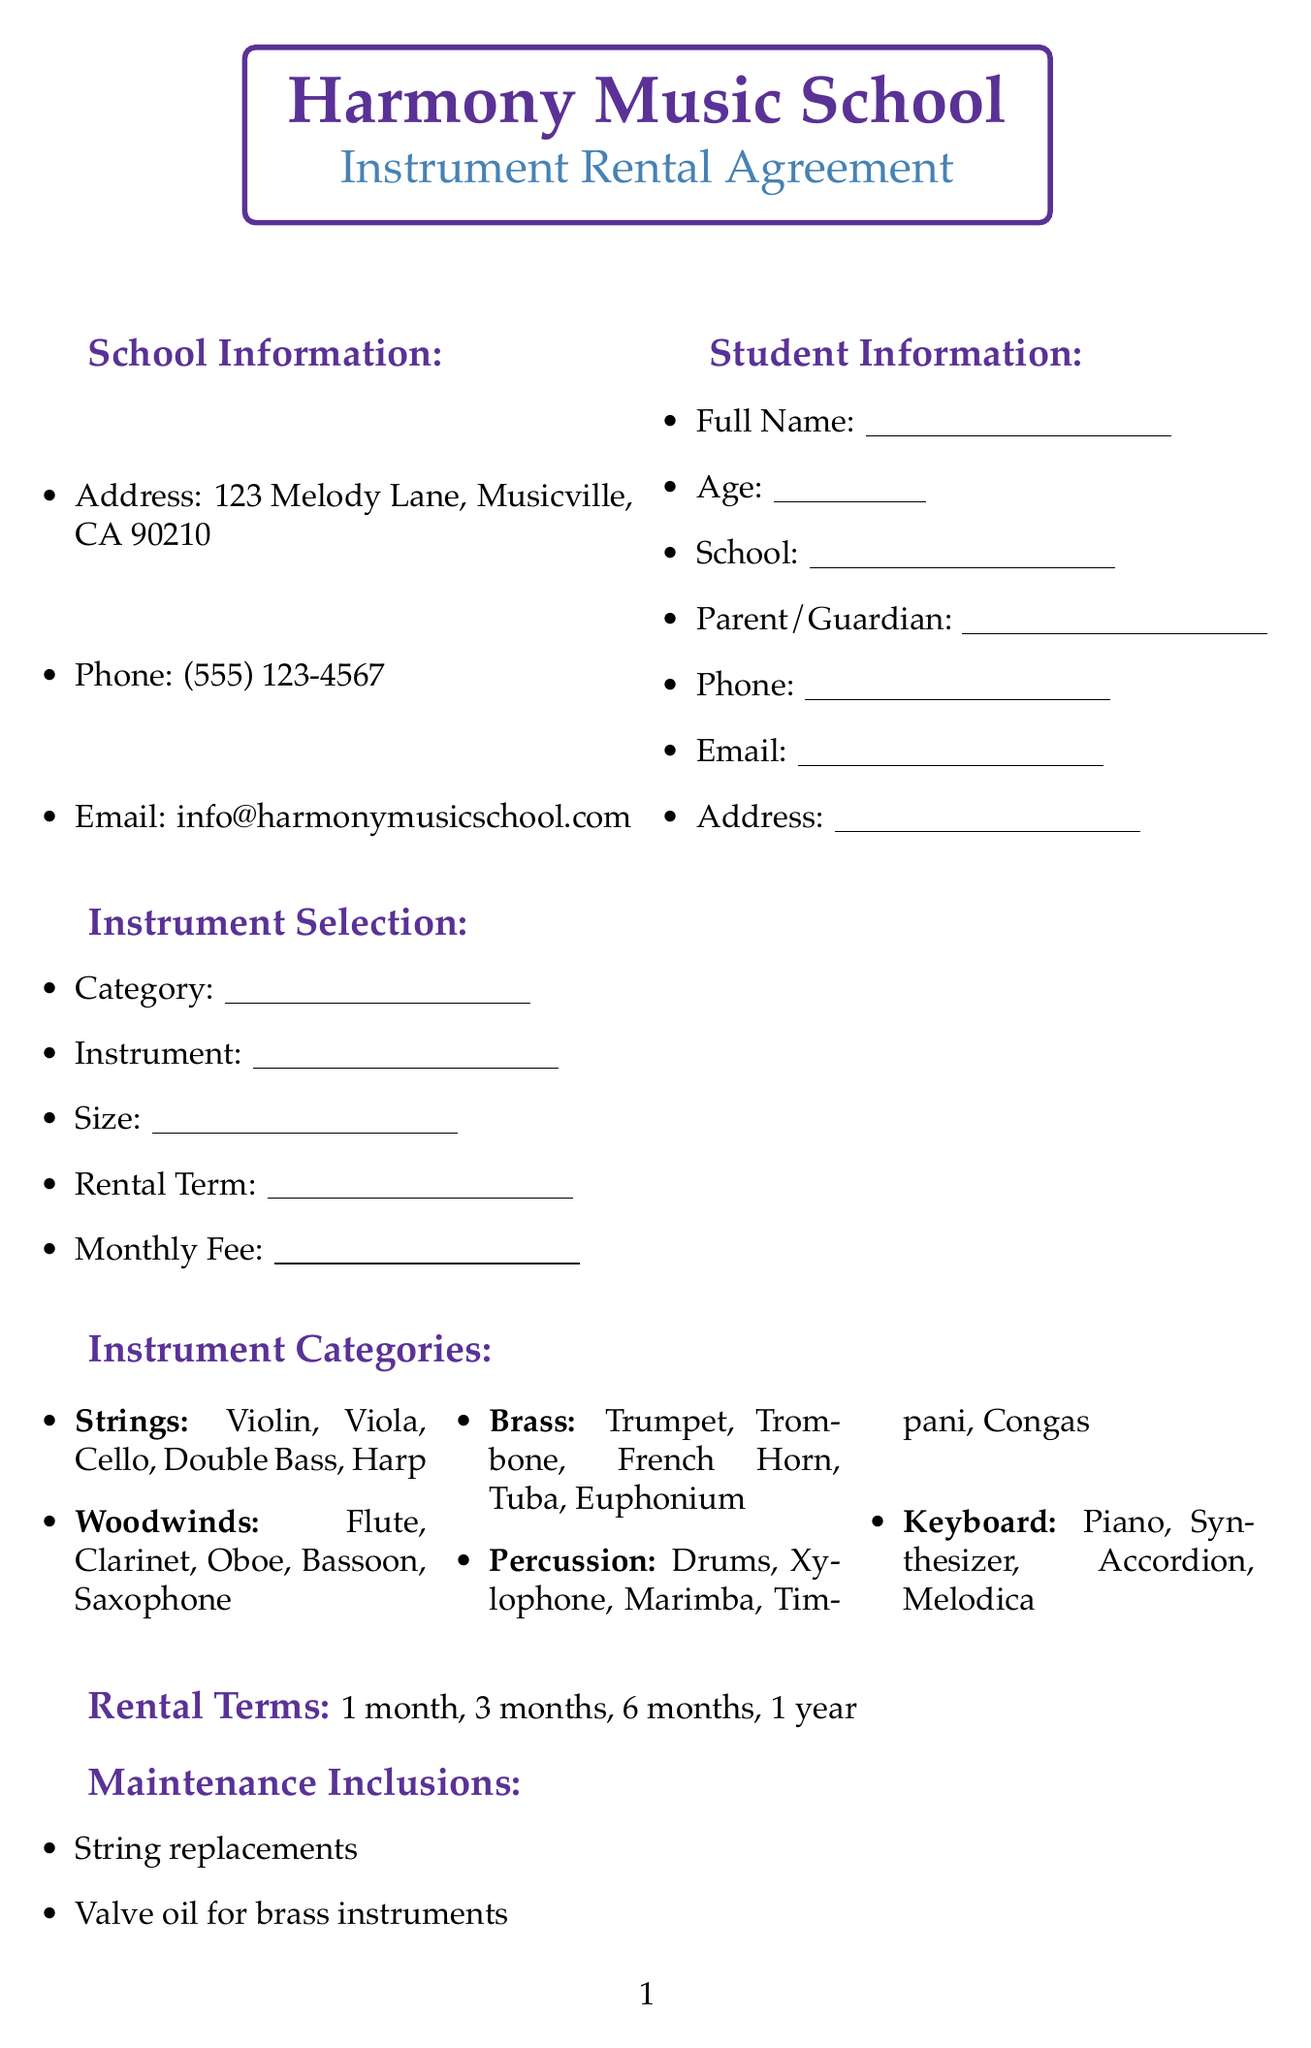What is the name of the school? The name of the school is stated at the top of the document under school information.
Answer: Harmony Music School How many instrument categories are listed? The document lists different categories of instruments, which can be counted for this answer.
Answer: 5 What is included in the maintenance for rented instruments? The document specifies various maintenance inclusions that are provided for rented instruments and lists them.
Answer: String replacements What is the longest rental term available? The rental terms are listed in the document, and this question asks for the maximum duration.
Answer: 1 year What kind of classes must students agree to participate in during the rental period? The document outlines the types of classes related to music appreciation that the students must engage in.
Answer: music appreciation class Which ensemble opportunity is available for students? The document mentions various ensemble opportunities available to students, and one can be selected as an example.
Answer: School Orchestra What is the address of Harmony Music School? The school’s address is mentioned under the school information, which can be directly referenced.
Answer: 123 Melody Lane, Musicville, CA 90210 What is the phone number for Harmony Music School? The phone number is explicitly stated in the school information within the document.
Answer: (555) 123-4567 